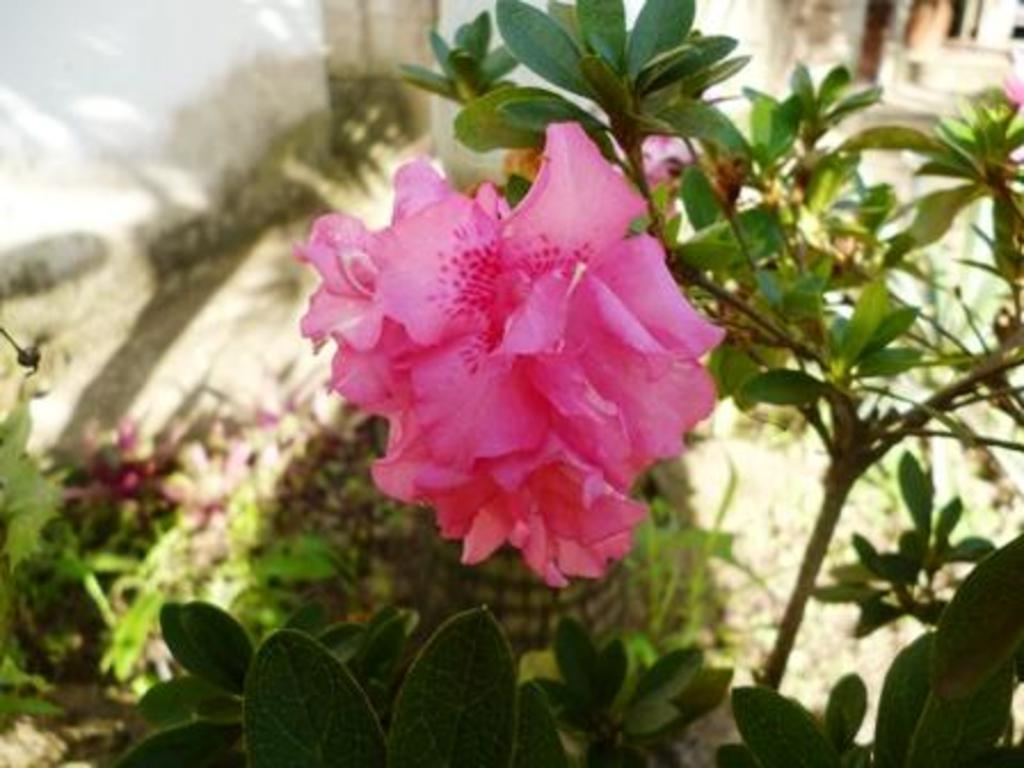What is the main subject of the image? There is a flower in the image. To which plant does the flower belong? The flower belongs to a plant. What other parts of the plant can be seen in the image? There are leaves visible in the image. What type of crate is used to store the reason in the image? There is no crate or reason present in the image; it features a flower and leaves. 